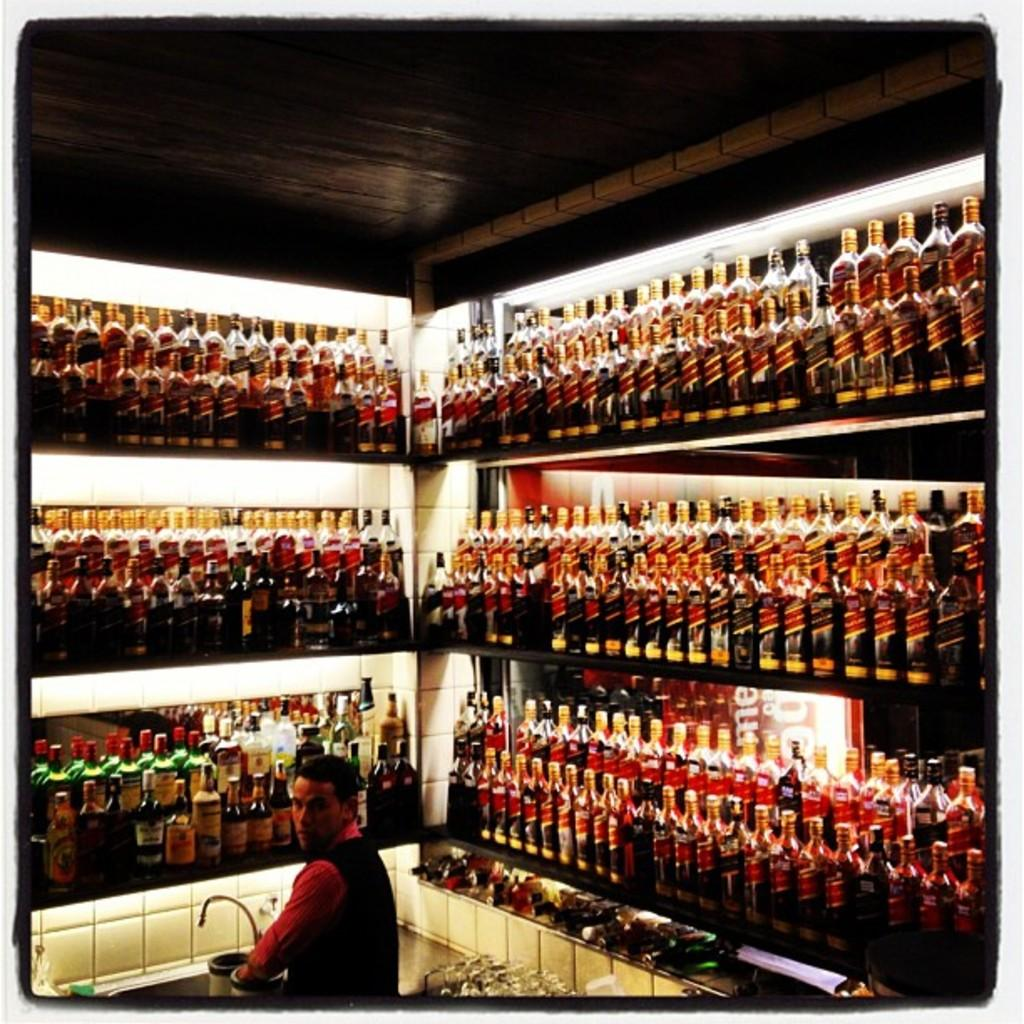What objects are arranged in shelves in the image? There are beverage bottles arranged in shelves in the image. What is the person in the image doing? The person is standing at a sink. How many lizards are crawling on the top shelf in the image? There are no lizards present in the image. What is the root of the beverage bottles in the image? The provided facts do not mention any roots associated with the beverage bottles. 